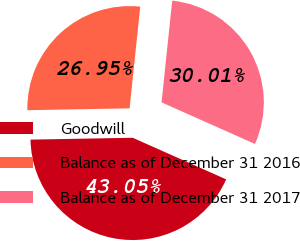Convert chart to OTSL. <chart><loc_0><loc_0><loc_500><loc_500><pie_chart><fcel>Goodwill<fcel>Balance as of December 31 2016<fcel>Balance as of December 31 2017<nl><fcel>43.05%<fcel>26.95%<fcel>30.01%<nl></chart> 